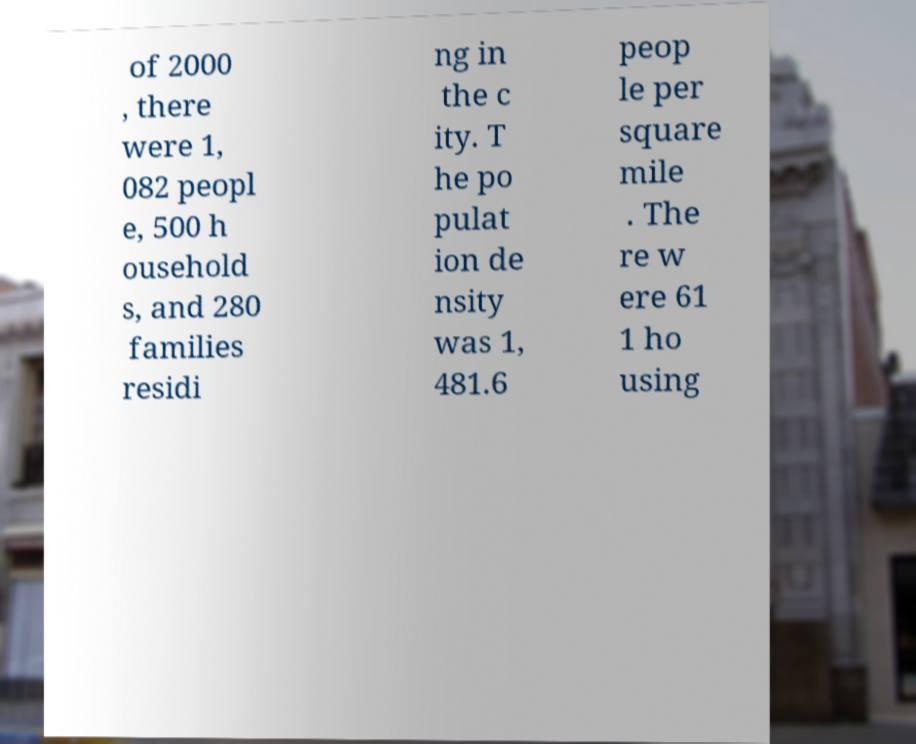Can you read and provide the text displayed in the image?This photo seems to have some interesting text. Can you extract and type it out for me? of 2000 , there were 1, 082 peopl e, 500 h ousehold s, and 280 families residi ng in the c ity. T he po pulat ion de nsity was 1, 481.6 peop le per square mile . The re w ere 61 1 ho using 